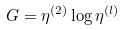Convert formula to latex. <formula><loc_0><loc_0><loc_500><loc_500>G = \eta ^ { ( 2 ) } \log \eta ^ { ( l ) }</formula> 